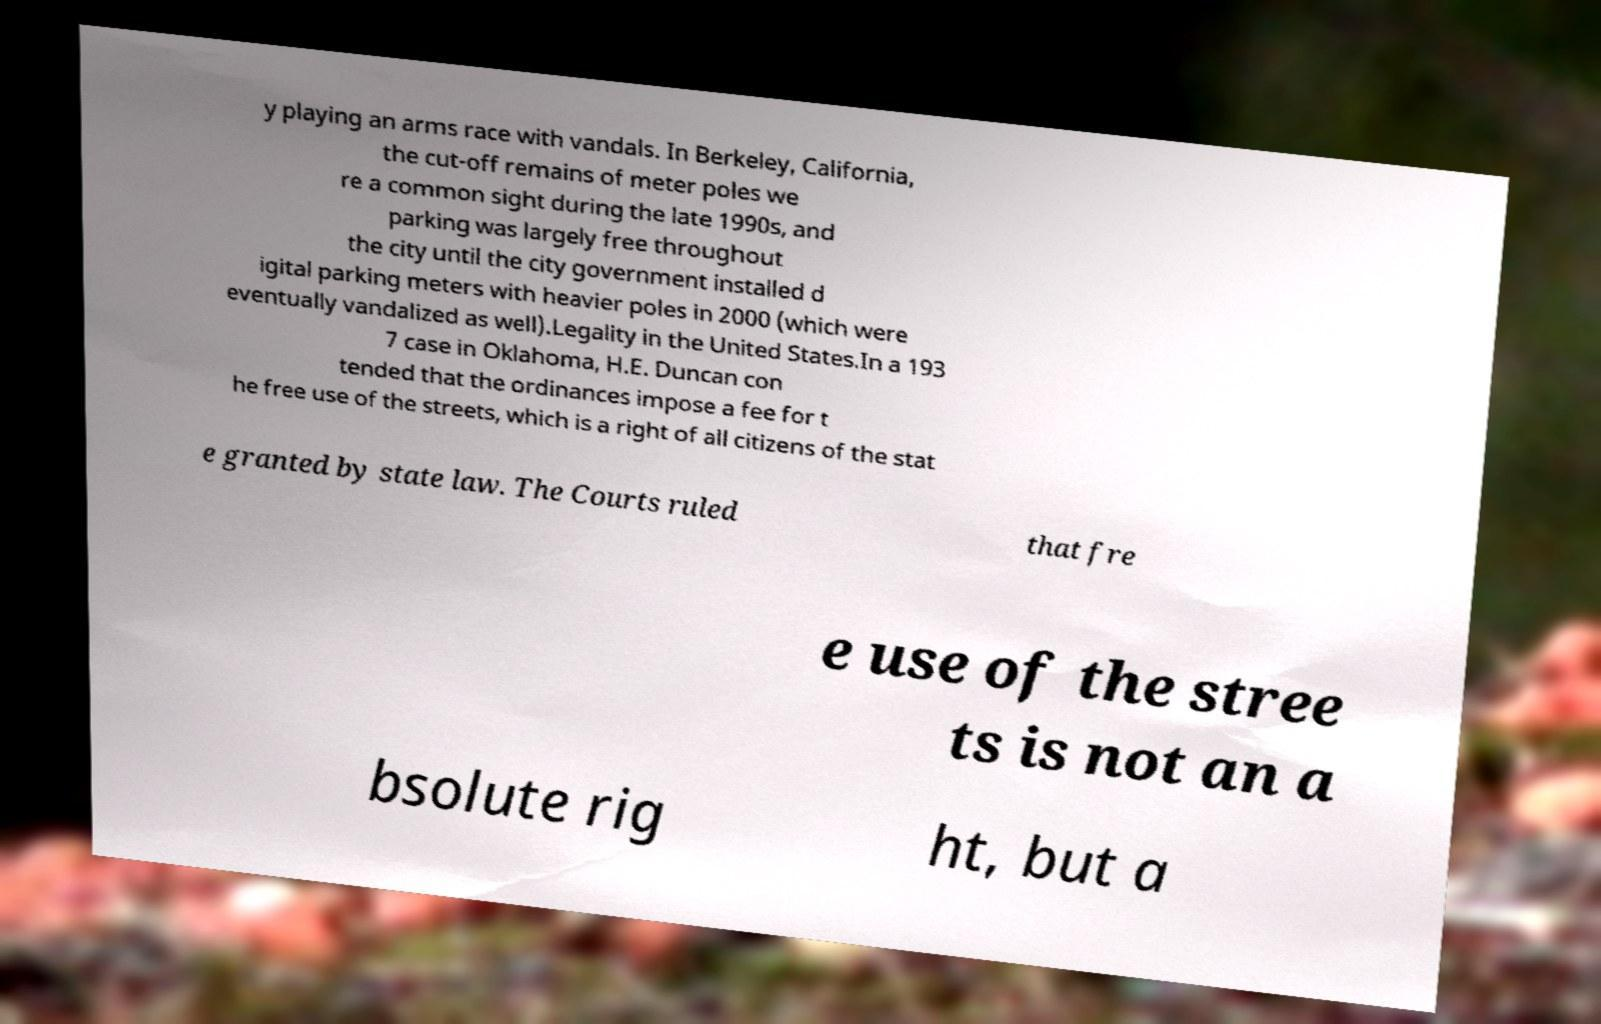Could you assist in decoding the text presented in this image and type it out clearly? y playing an arms race with vandals. In Berkeley, California, the cut-off remains of meter poles we re a common sight during the late 1990s, and parking was largely free throughout the city until the city government installed d igital parking meters with heavier poles in 2000 (which were eventually vandalized as well).Legality in the United States.In a 193 7 case in Oklahoma, H.E. Duncan con tended that the ordinances impose a fee for t he free use of the streets, which is a right of all citizens of the stat e granted by state law. The Courts ruled that fre e use of the stree ts is not an a bsolute rig ht, but a 